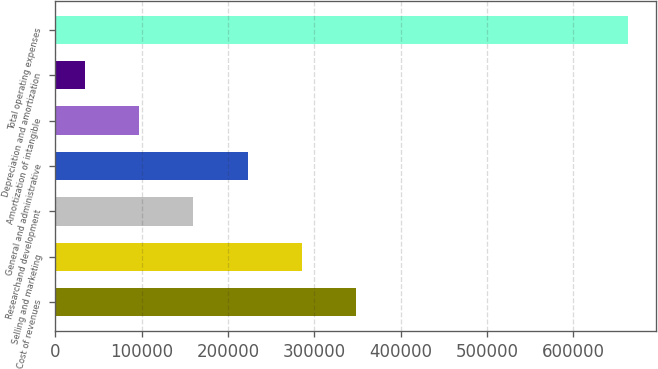Convert chart. <chart><loc_0><loc_0><loc_500><loc_500><bar_chart><fcel>Cost of revenues<fcel>Selling and marketing<fcel>Researchand development<fcel>General and administrative<fcel>Amortization of intangible<fcel>Depreciation and amortization<fcel>Total operating expenses<nl><fcel>348442<fcel>285618<fcel>159969<fcel>222794<fcel>97144.5<fcel>34320<fcel>662565<nl></chart> 